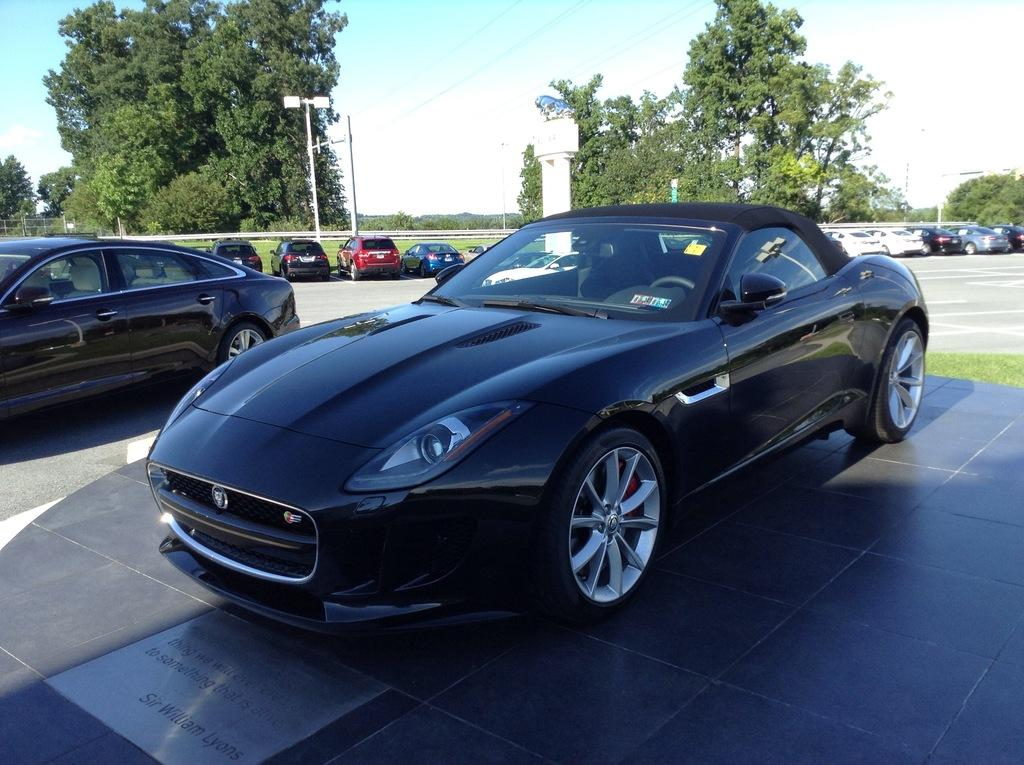What type of vehicles can be seen in the image? There are cars in the image. What is on the ground in the image? There is grass on the ground in the image. What type of vegetation is present in the image? There are trees in the image. What are the poles used for in the image? The purpose of the poles is not specified in the image, but they could be used for various purposes such as lighting or signage. What is visible at the top of the image? The sky is visible at the top of the image. What type of current can be seen flowing through the bedroom in the image? There is no bedroom or current present in the image; it features cars, grass, trees, poles, and the sky. 